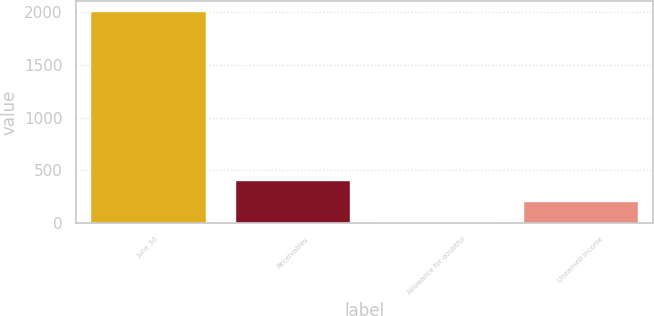Convert chart. <chart><loc_0><loc_0><loc_500><loc_500><bar_chart><fcel>June 30<fcel>Receivables<fcel>Allowance for doubtful<fcel>Unearned income<nl><fcel>2008<fcel>407.92<fcel>7.9<fcel>207.91<nl></chart> 